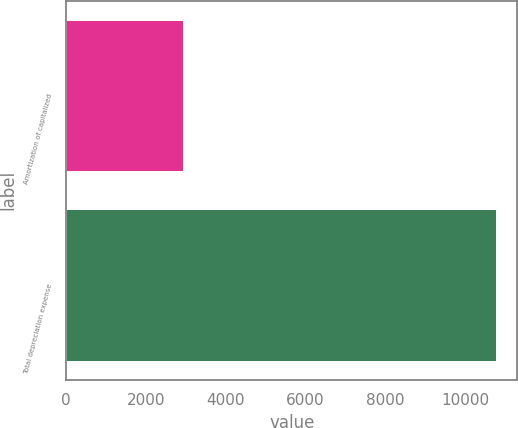Convert chart to OTSL. <chart><loc_0><loc_0><loc_500><loc_500><bar_chart><fcel>Amortization of capitalized<fcel>Total depreciation expense<nl><fcel>2938<fcel>10763<nl></chart> 